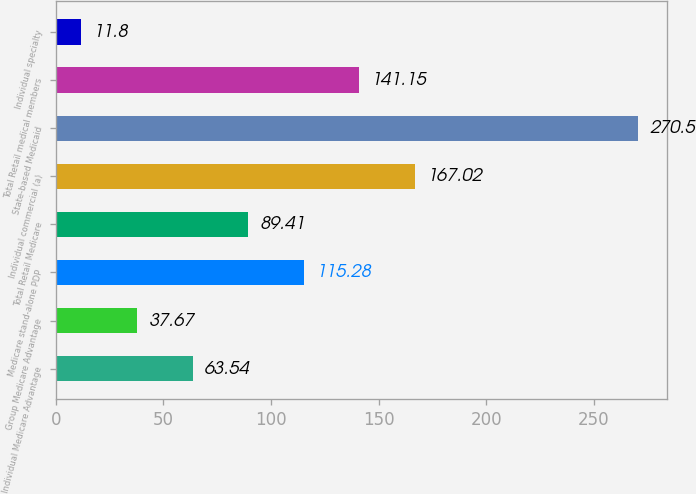<chart> <loc_0><loc_0><loc_500><loc_500><bar_chart><fcel>Individual Medicare Advantage<fcel>Group Medicare Advantage<fcel>Medicare stand-alone PDP<fcel>Total Retail Medicare<fcel>Individual commercial (a)<fcel>State-based Medicaid<fcel>Total Retail medical members<fcel>Individual specialty<nl><fcel>63.54<fcel>37.67<fcel>115.28<fcel>89.41<fcel>167.02<fcel>270.5<fcel>141.15<fcel>11.8<nl></chart> 